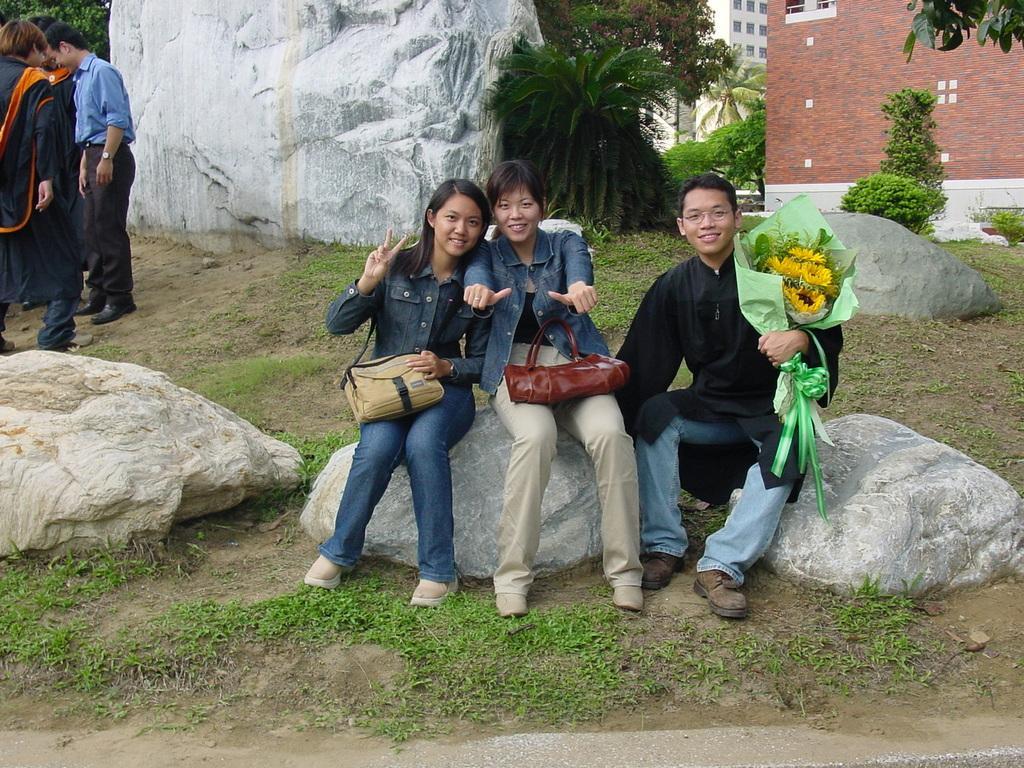Can you describe this image briefly? This image is taken in outdoors. In the middle of the image three people are sitting on the rock, two woman and a man holding a bouquet in his hand. In the left side of the image there is a rock. In the bottom of the image there is a ground with grass. In the right side of the image there is a building with window, few people are standing on the ground. In the background there is a rock, few trees and plants and building with windows. 